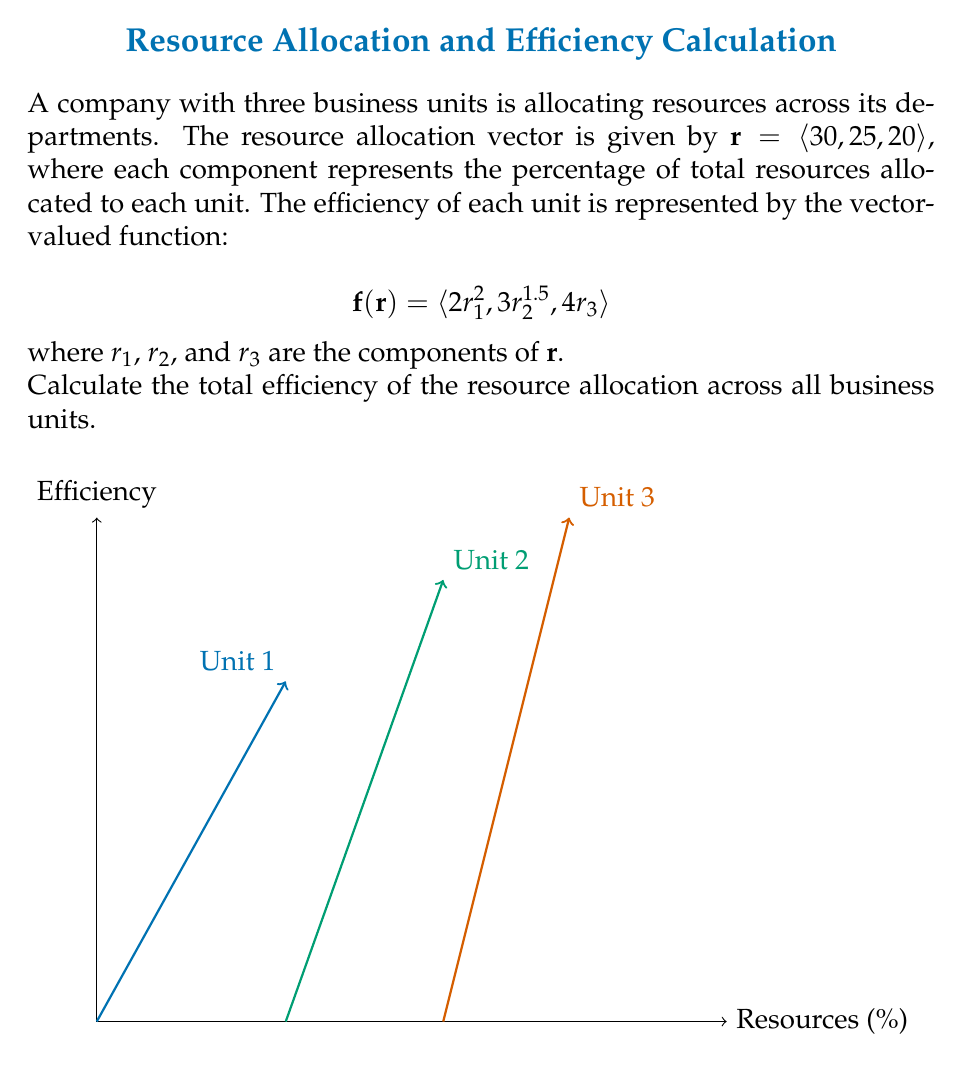Provide a solution to this math problem. To calculate the total efficiency, we need to follow these steps:

1) First, let's calculate the efficiency for each unit using the given vector-valued function:

   For Unit 1: $f_1(r_1) = 2r_1^2 = 2(30)^2 = 2(900) = 1800$
   
   For Unit 2: $f_2(r_2) = 3r_2^{1.5} = 3(25)^{1.5} = 3(125) = 375$
   
   For Unit 3: $f_3(r_3) = 4r_3 = 4(20) = 80$

2) The total efficiency is the sum of the efficiencies of all units. In vector notation, this is equivalent to finding the magnitude of the efficiency vector:

   $$\text{Total Efficiency} = |\mathbf{f}(\mathbf{r})| = \sqrt{f_1(r_1)^2 + f_2(r_2)^2 + f_3(r_3)^2}$$

3) Substituting the values we calculated:

   $$\text{Total Efficiency} = \sqrt{1800^2 + 375^2 + 80^2}$$

4) Calculating:

   $$\text{Total Efficiency} = \sqrt{3,240,000 + 140,625 + 6,400} = \sqrt{3,387,025} = 1840.93$$

Thus, the total efficiency of the resource allocation across all business units is approximately 1840.93 units.
Answer: 1840.93 